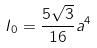Convert formula to latex. <formula><loc_0><loc_0><loc_500><loc_500>I _ { 0 } = \frac { 5 \sqrt { 3 } } { 1 6 } a ^ { 4 }</formula> 